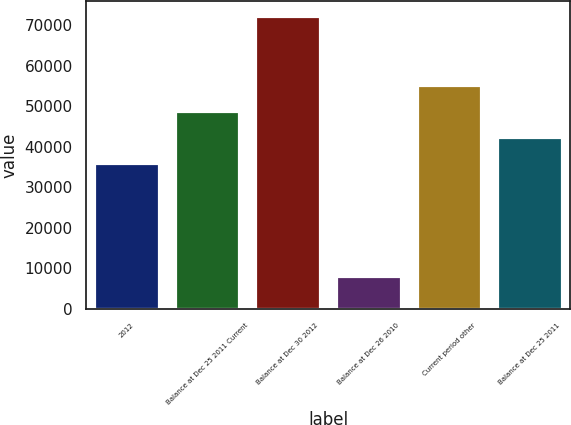Convert chart. <chart><loc_0><loc_0><loc_500><loc_500><bar_chart><fcel>2012<fcel>Balance at Dec 25 2011 Current<fcel>Balance at Dec 30 2012<fcel>Balance at Dec 26 2010<fcel>Current period other<fcel>Balance at Dec 25 2011<nl><fcel>35943<fcel>48774.6<fcel>72307<fcel>8149<fcel>55190.4<fcel>42358.8<nl></chart> 